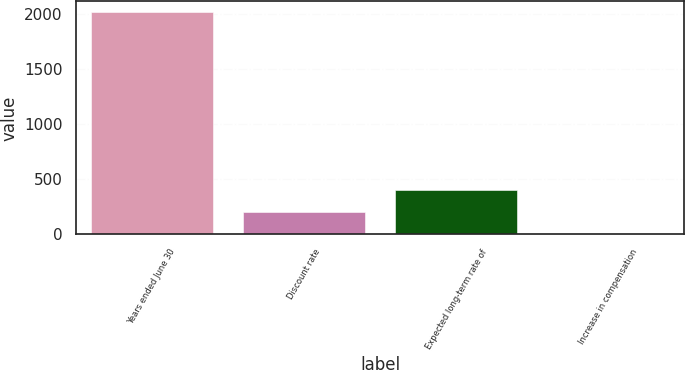Convert chart to OTSL. <chart><loc_0><loc_0><loc_500><loc_500><bar_chart><fcel>Years ended June 30<fcel>Discount rate<fcel>Expected long-term rate of<fcel>Increase in compensation<nl><fcel>2012<fcel>204.8<fcel>405.6<fcel>4<nl></chart> 